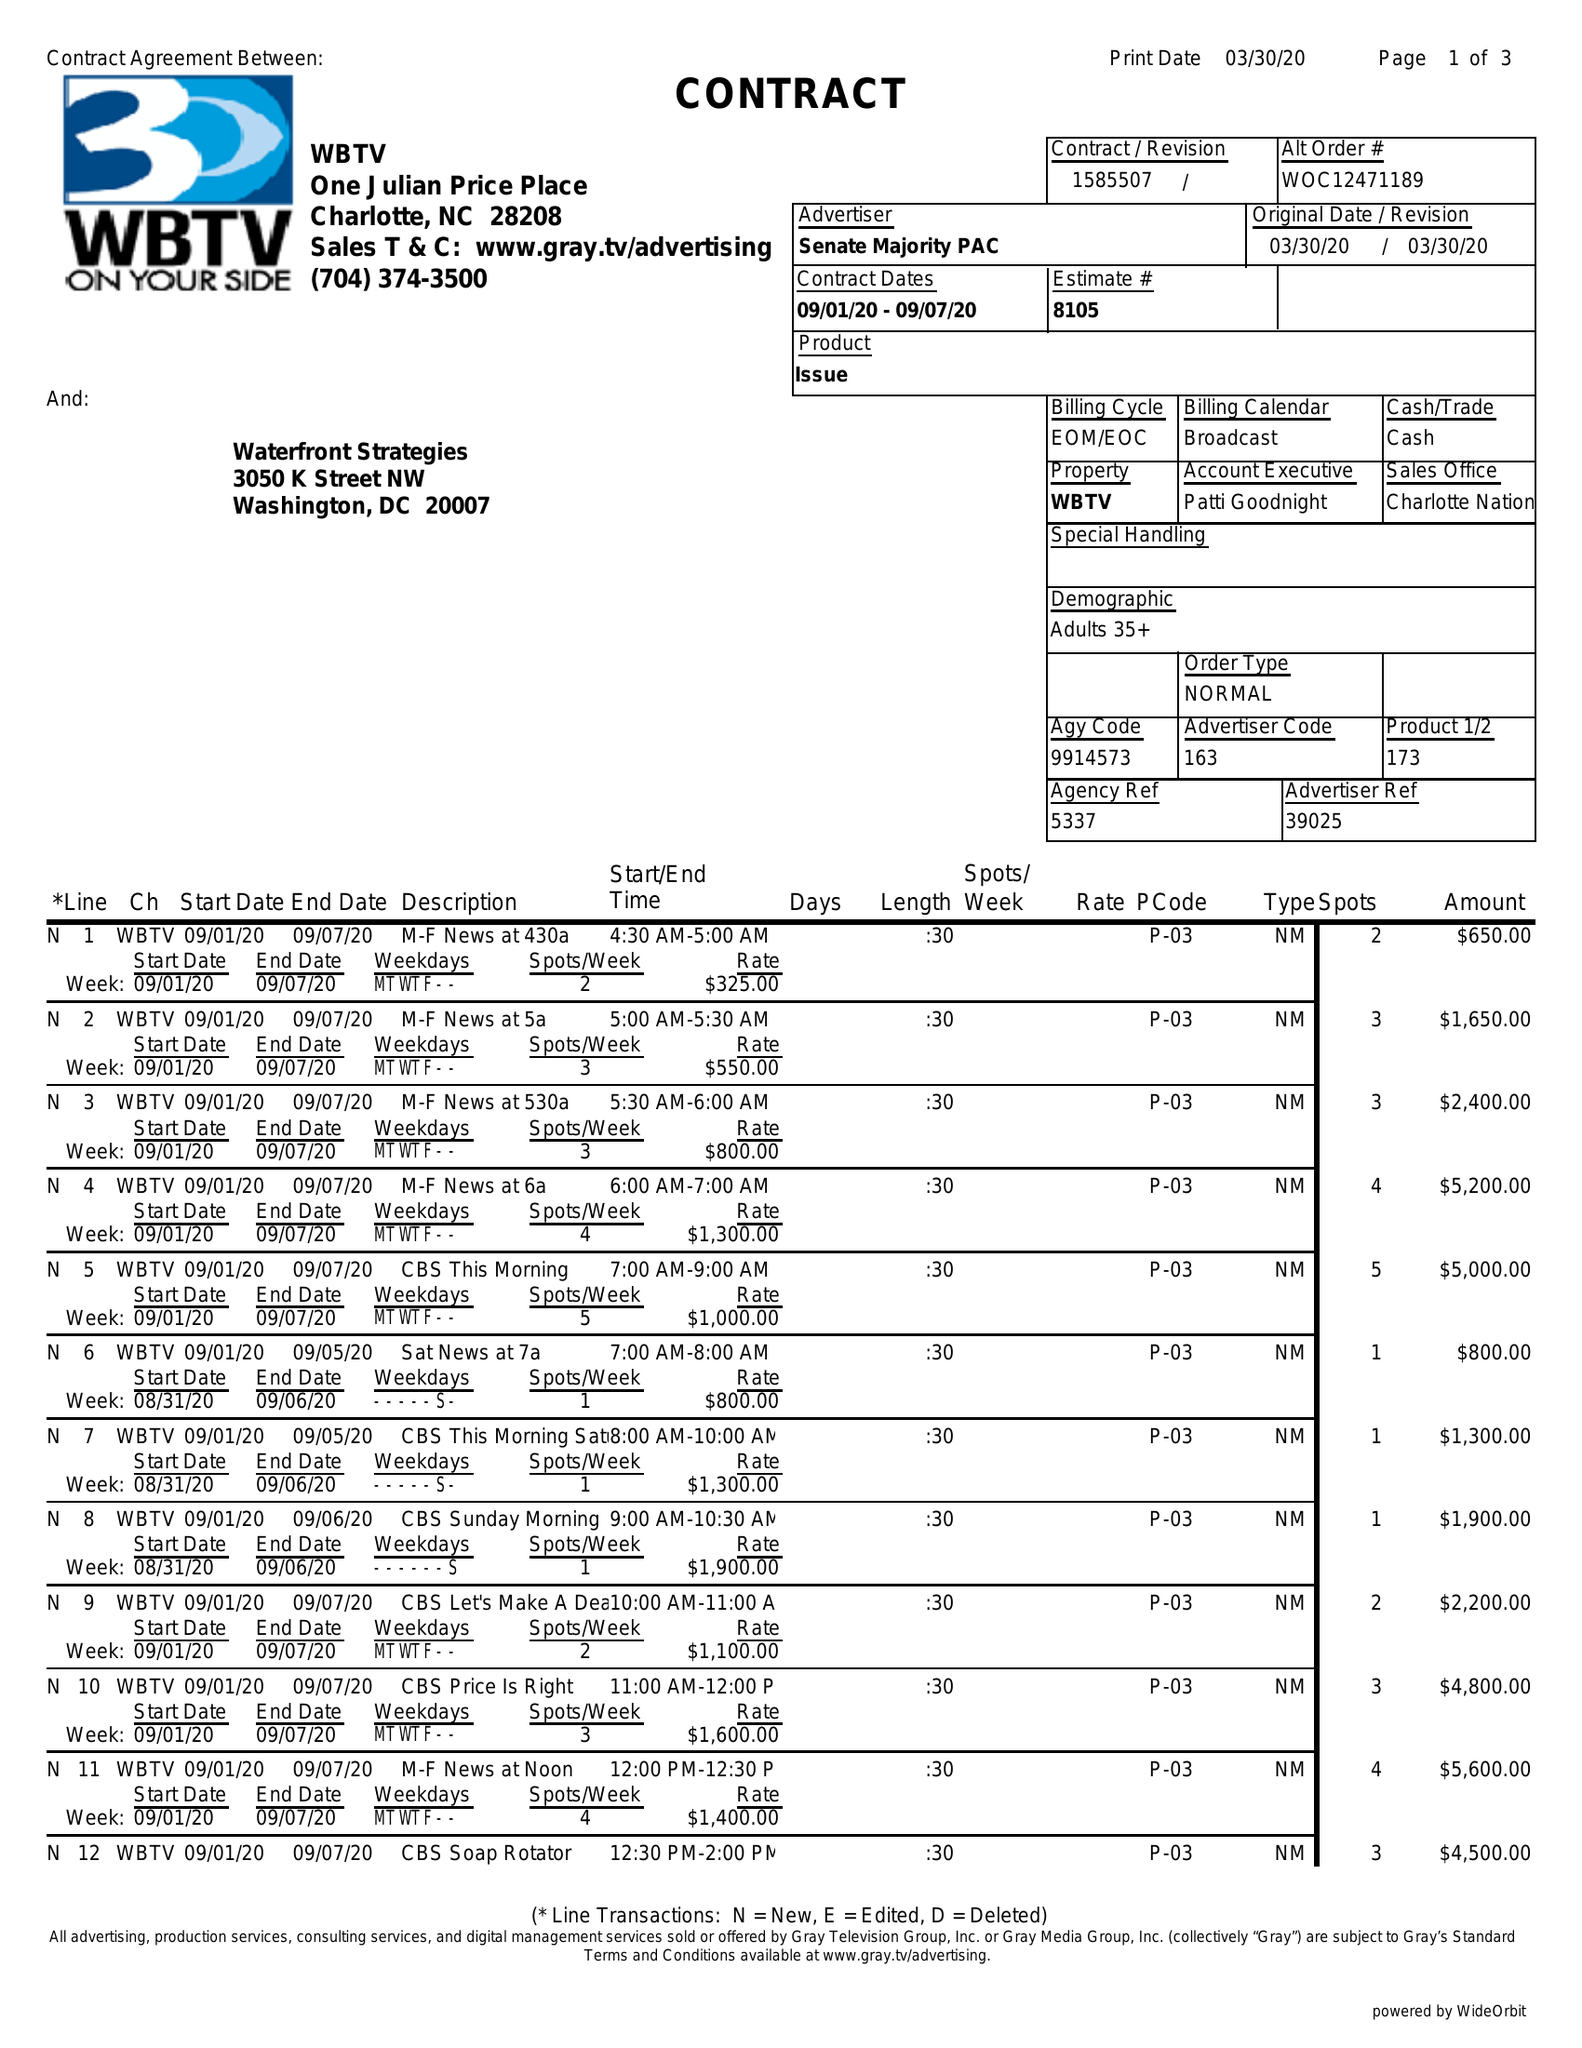What is the value for the contract_num?
Answer the question using a single word or phrase. 1585507 